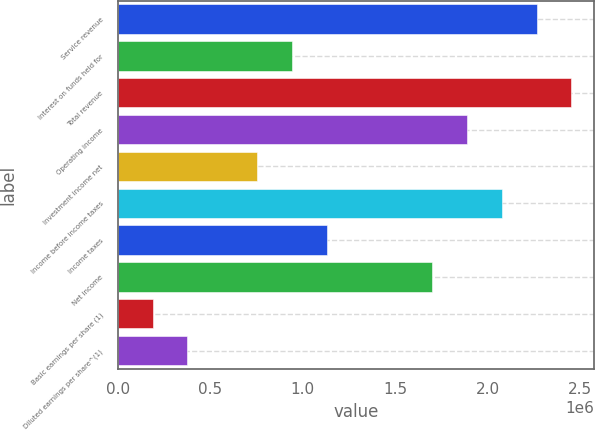Convert chart. <chart><loc_0><loc_0><loc_500><loc_500><bar_chart><fcel>Service revenue<fcel>Interest on funds held for<fcel>Total revenue<fcel>Operating income<fcel>Investment income net<fcel>Income before income taxes<fcel>Income taxes<fcel>Net income<fcel>Basic earnings per share (1)<fcel>Diluted earnings per share^(1)<nl><fcel>2.26436e+06<fcel>943482<fcel>2.45305e+06<fcel>1.88696e+06<fcel>754786<fcel>2.07566e+06<fcel>1.13218e+06<fcel>1.69827e+06<fcel>188697<fcel>377393<nl></chart> 